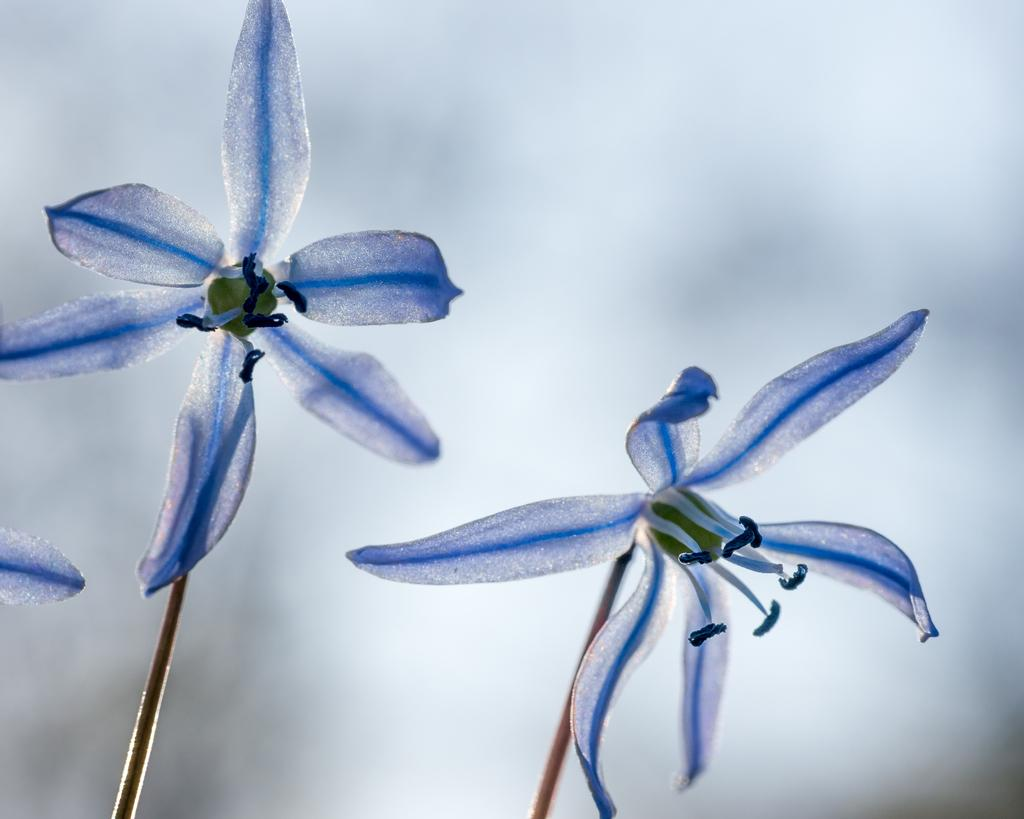How many flowers are present in the image? There are two flowers in the image. What colors are the flowers? One flower is white in color, and the other flower is blue in color. What is the color of the object between the flowers? The object between the flowers is green in color. What is the value of the fictional slave depicted in the image? There is no fictional slave present in the image; it features two flowers and a green object between them. 